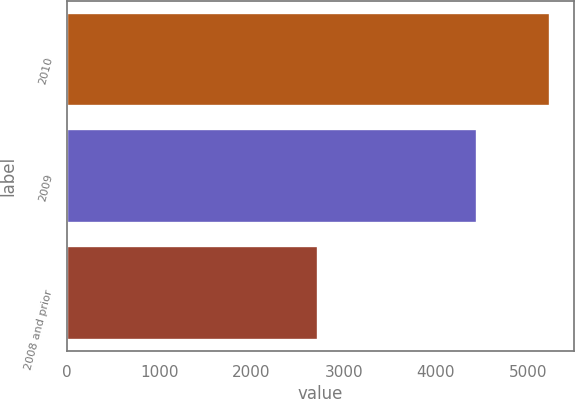Convert chart. <chart><loc_0><loc_0><loc_500><loc_500><bar_chart><fcel>2010<fcel>2009<fcel>2008 and prior<nl><fcel>5236<fcel>4443<fcel>2722<nl></chart> 